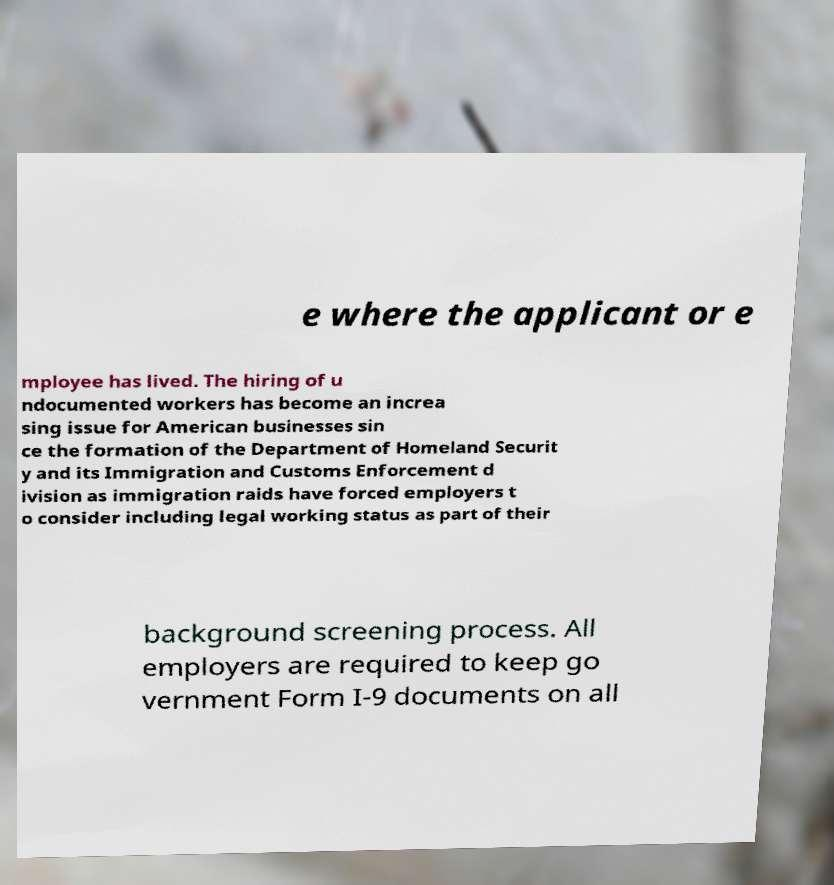What messages or text are displayed in this image? I need them in a readable, typed format. e where the applicant or e mployee has lived. The hiring of u ndocumented workers has become an increa sing issue for American businesses sin ce the formation of the Department of Homeland Securit y and its Immigration and Customs Enforcement d ivision as immigration raids have forced employers t o consider including legal working status as part of their background screening process. All employers are required to keep go vernment Form I-9 documents on all 